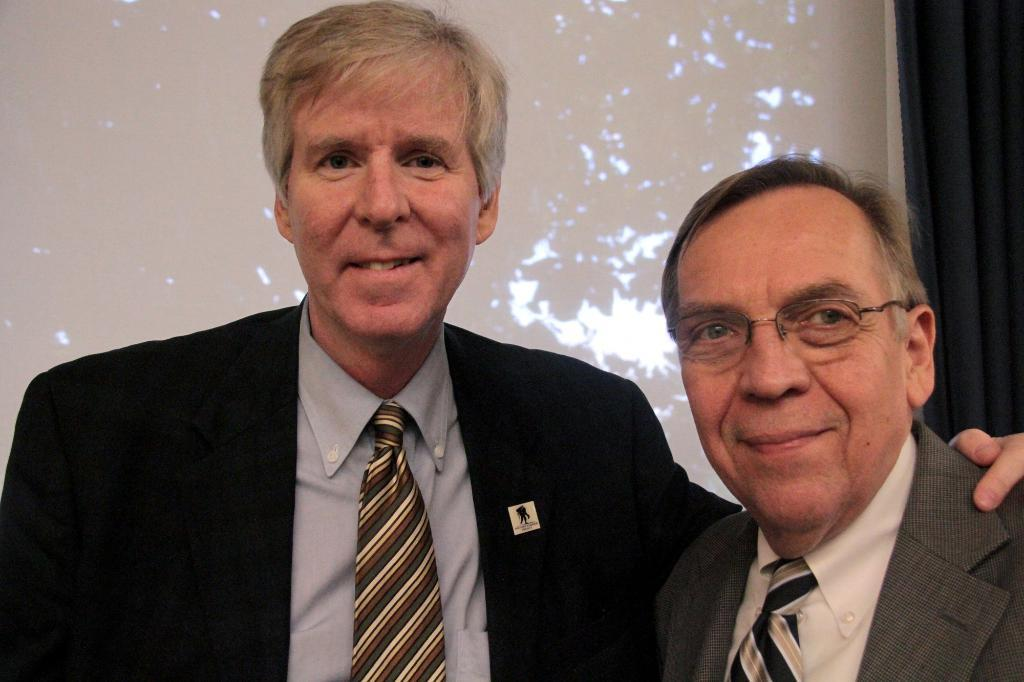How many people are in the image? There are two men in the image. What are the men wearing? The men are wearing suits. What expression do the men have in the image? The men are smiling. What are the men doing in the image? The men are posing for the picture. What can be seen in the background of the image? There are curtains in the background of the image. What colors are the curtains? The curtains are in blue and white colors. What type of disgust can be seen on the men's faces in the image? There is no indication of disgust on the men's faces in the image; they are smiling. What type of good-bye gesture are the men making in the image? There is no good-bye gesture visible in the image; the men are posing for the picture. 